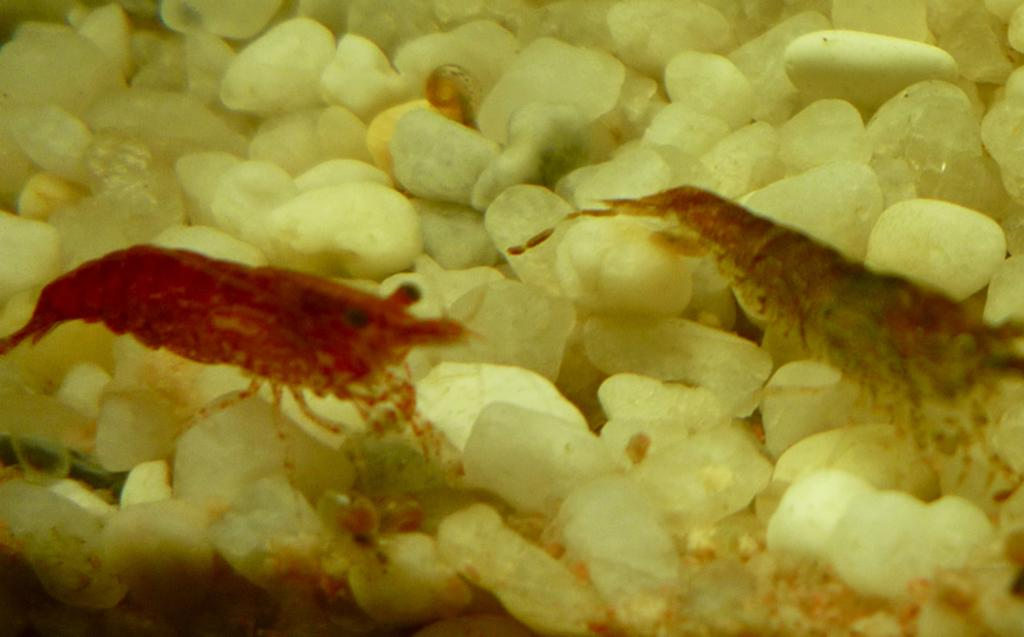What type of living organisms can be seen in the image? Insects can be seen in the image. What type of inanimate objects are present in the image? Stones can be seen in the image. Where is the seat located in the image? There is no seat present in the image. What type of farming equipment can be seen in the image? There is no farming equipment, such as a plough, present in the image. 